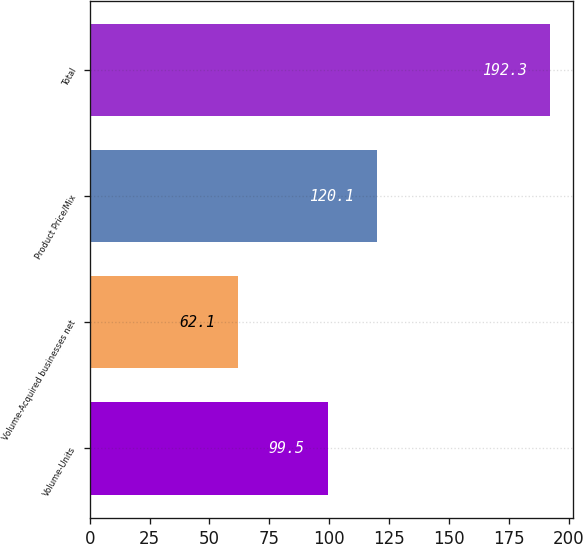Convert chart to OTSL. <chart><loc_0><loc_0><loc_500><loc_500><bar_chart><fcel>Volume-Units<fcel>Volume-Acquired businesses net<fcel>Product Price/Mix<fcel>Total<nl><fcel>99.5<fcel>62.1<fcel>120.1<fcel>192.3<nl></chart> 